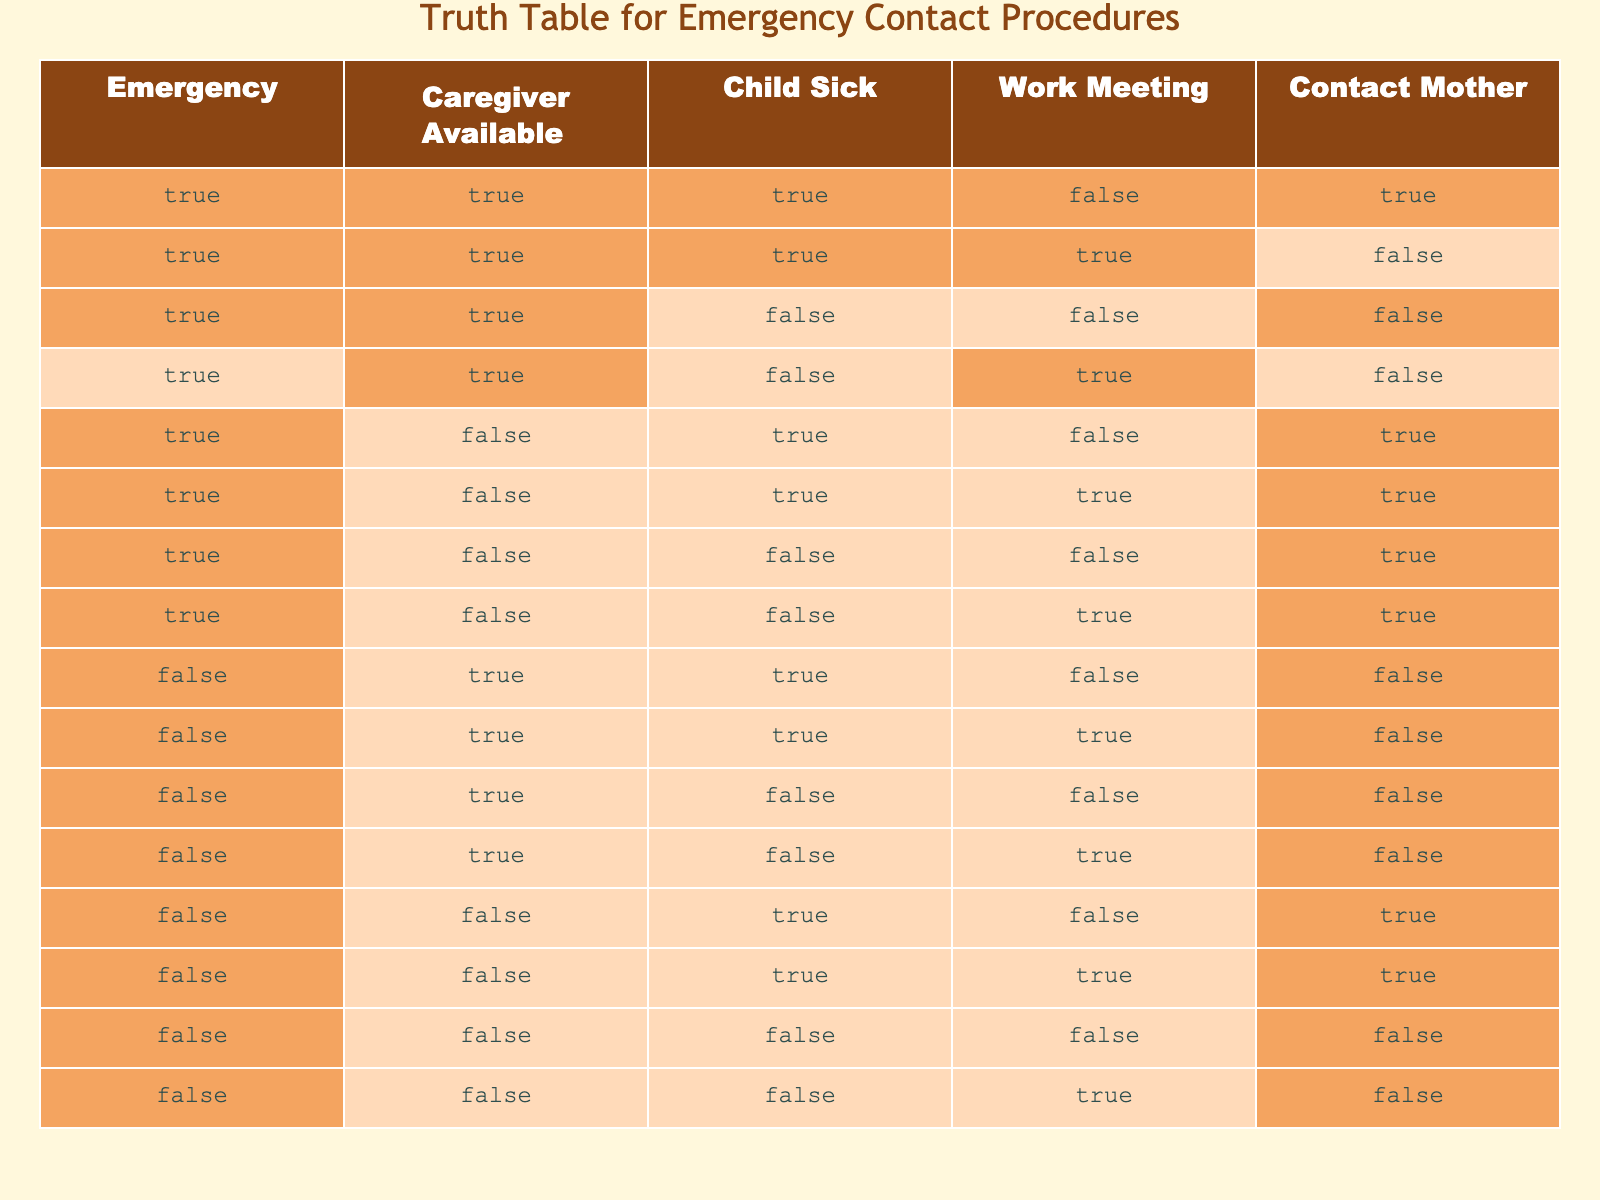What is the value for "Contact Mother" when there is an emergency, the caregiver is available, and the child is sick? To answer this, we find the row with "Emergency" = TRUE, "Caregiver Available" = TRUE, and "Child Sick" = TRUE. This condition matches the first row of the table, where "Contact Mother" is TRUE.
Answer: TRUE How many total conditions allow contacting the mother when the caregiver is not available? We look for rows where "Caregiver Available" is FALSE. In those rows, we count how many instances have "Contact Mother" as TRUE. The rows with "Caregiver Available" = FALSE that have "Contact Mother" = TRUE are rows 5, 6, 7, and 8. There are 4 instances.
Answer: 4 Is it true that if the child is sick and there is an emergency, then contacting the mother is always possible? We inspect the rows where "Child Sick" = TRUE and "Emergency" = TRUE. Out of these, we can see the first two rows as relevant: in the first row, we can contact the mother, but in the second row, we cannot. Therefore, it is not always possible.
Answer: FALSE What percentage of the cases where there is no emergency allows contacting the mother? We first identify rows where "Emergency" = FALSE. There are 7 such rows (rows 9 to 15). Among these, only rows 12 and 13 have "Contact Mother" = TRUE, giving us 2 out of 7. To find the percentage, we calculate (2/7) * 100, which is approximately 28.57%.
Answer: 28.57% When there is an emergency, and the caregiver is available, how many times is the child not sick? We check the total number of rows with "Emergency" = TRUE and "Caregiver Available" = TRUE, which gives us 4 rows. Then, we see that in rows 3 to 4, the child is not sick. This sums up to 2 instances where the child is not sick under these conditions.
Answer: 2 